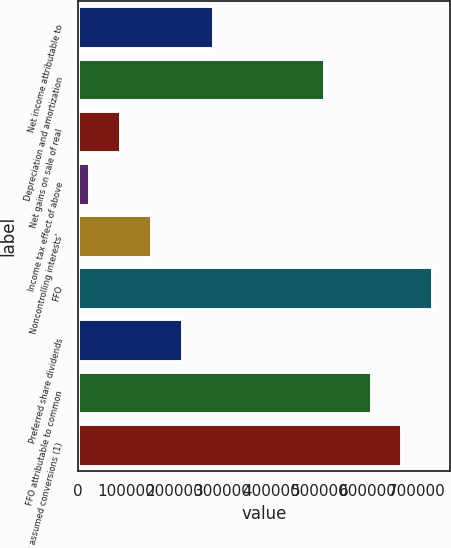Convert chart. <chart><loc_0><loc_0><loc_500><loc_500><bar_chart><fcel>Net income attributable to<fcel>Depreciation and amortization<fcel>Net gains on sale of real<fcel>Income tax effect of above<fcel>Noncontrolling interests'<fcel>FFO<fcel>Preferred share dividends<fcel>FFO attributable to common<fcel>plus assumed conversions (1)<nl><fcel>278502<fcel>508572<fcel>86739.8<fcel>22819<fcel>150661<fcel>732793<fcel>214581<fcel>604951<fcel>668872<nl></chart> 